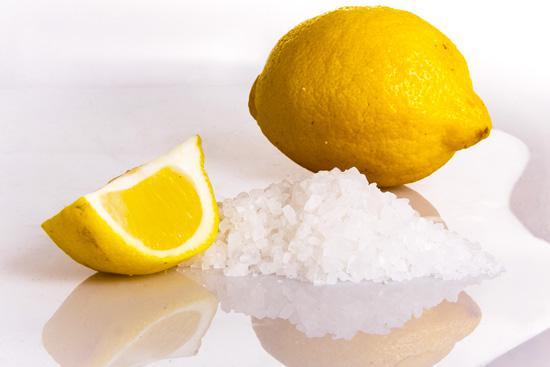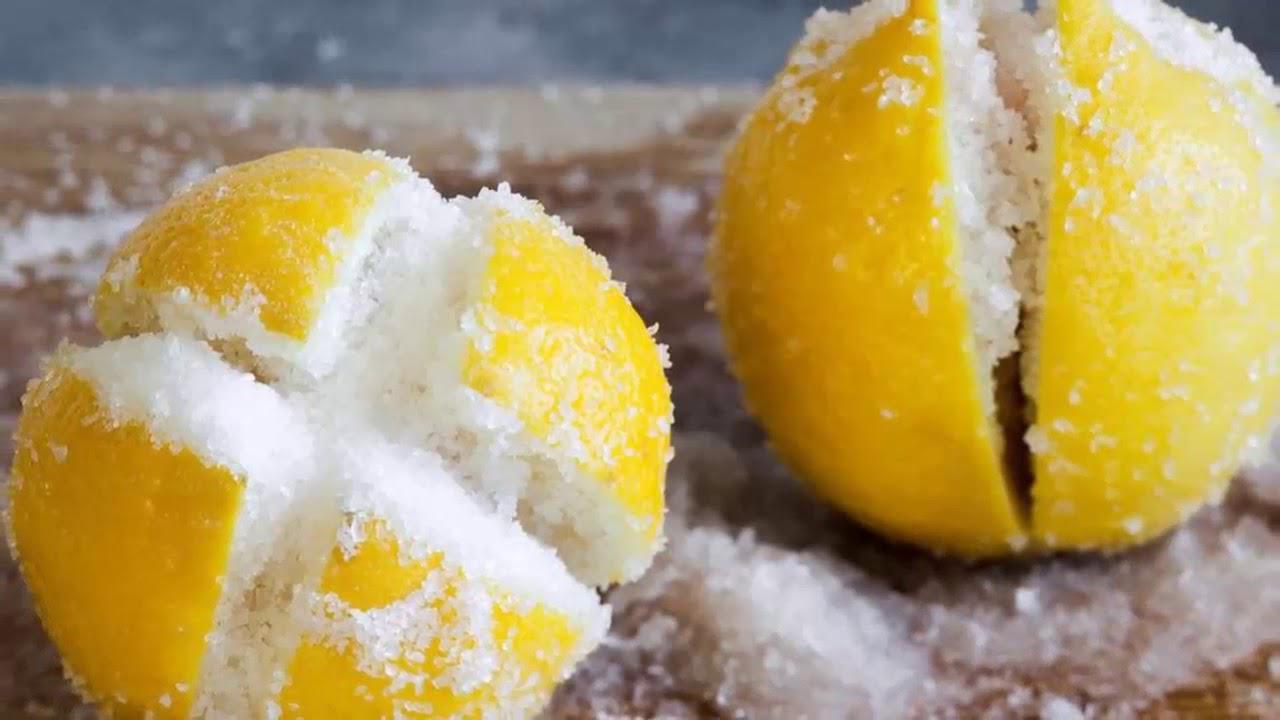The first image is the image on the left, the second image is the image on the right. Given the left and right images, does the statement "In one of the images, there is salt next to the lemons but not on any of them." hold true? Answer yes or no. Yes. The first image is the image on the left, the second image is the image on the right. Assess this claim about the two images: "The right image shows a lemon cross cut into four parts with salt poured on it.". Correct or not? Answer yes or no. Yes. 